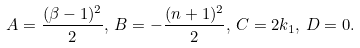Convert formula to latex. <formula><loc_0><loc_0><loc_500><loc_500>A = \frac { ( \beta - 1 ) ^ { 2 } } { 2 } , \, B = - \frac { ( n + 1 ) ^ { 2 } } { 2 } , \, C = 2 k _ { 1 } , \, D = 0 .</formula> 